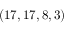Convert formula to latex. <formula><loc_0><loc_0><loc_500><loc_500>( 1 7 , 1 7 , 8 , 3 )</formula> 